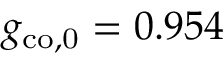Convert formula to latex. <formula><loc_0><loc_0><loc_500><loc_500>g _ { c o , 0 } = 0 . 9 5 4</formula> 